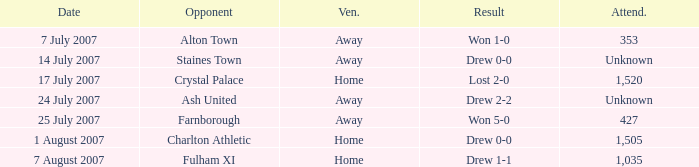Tell me the date with result of won 1-0 7 July 2007. 